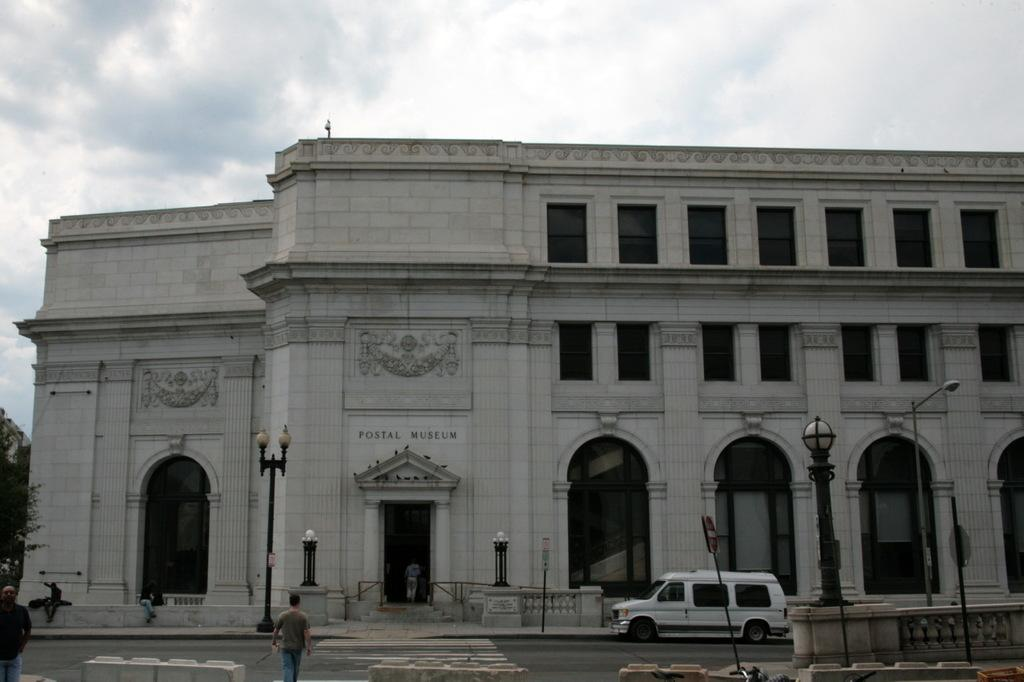Provide a one-sentence caption for the provided image. A museum is adorned with letters spelling out "Postal Museum.". 